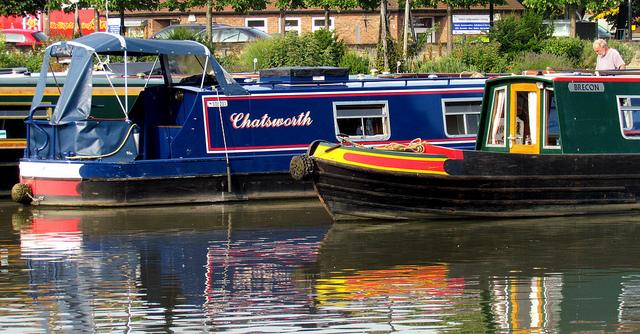What is on the deck of the closer boat?
Answer briefly. Rope. Are the boats in the water?
Give a very brief answer. Yes. Are the boats the same color?
Concise answer only. No. 